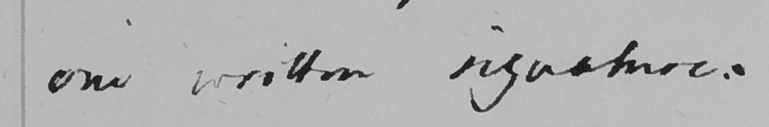What is written in this line of handwriting? one written signature . 